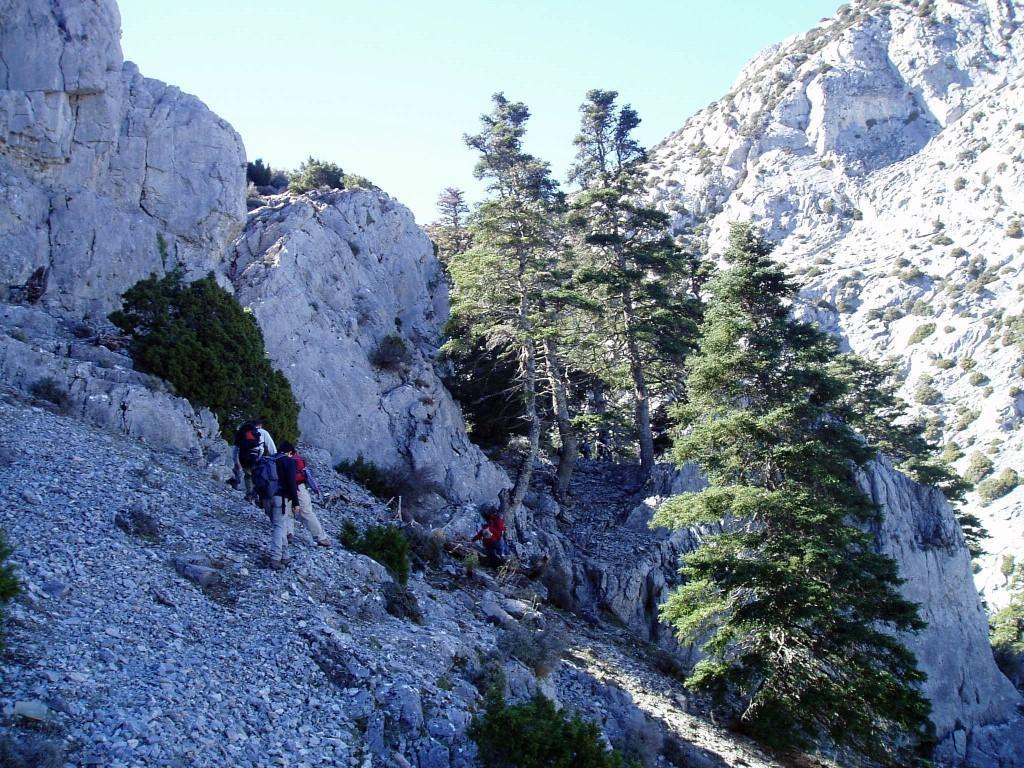In one or two sentences, can you explain what this image depicts? In this image, we can see rocks, trees, plants, stones and mountain. In the middle of the image, we can see few people. Few are wearing backpacks. Top of the image, there is a sky. 